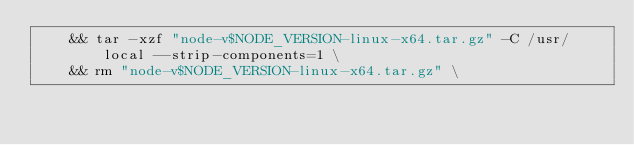Convert code to text. <code><loc_0><loc_0><loc_500><loc_500><_Dockerfile_>	&& tar -xzf "node-v$NODE_VERSION-linux-x64.tar.gz" -C /usr/local --strip-components=1 \
	&& rm "node-v$NODE_VERSION-linux-x64.tar.gz" \</code> 